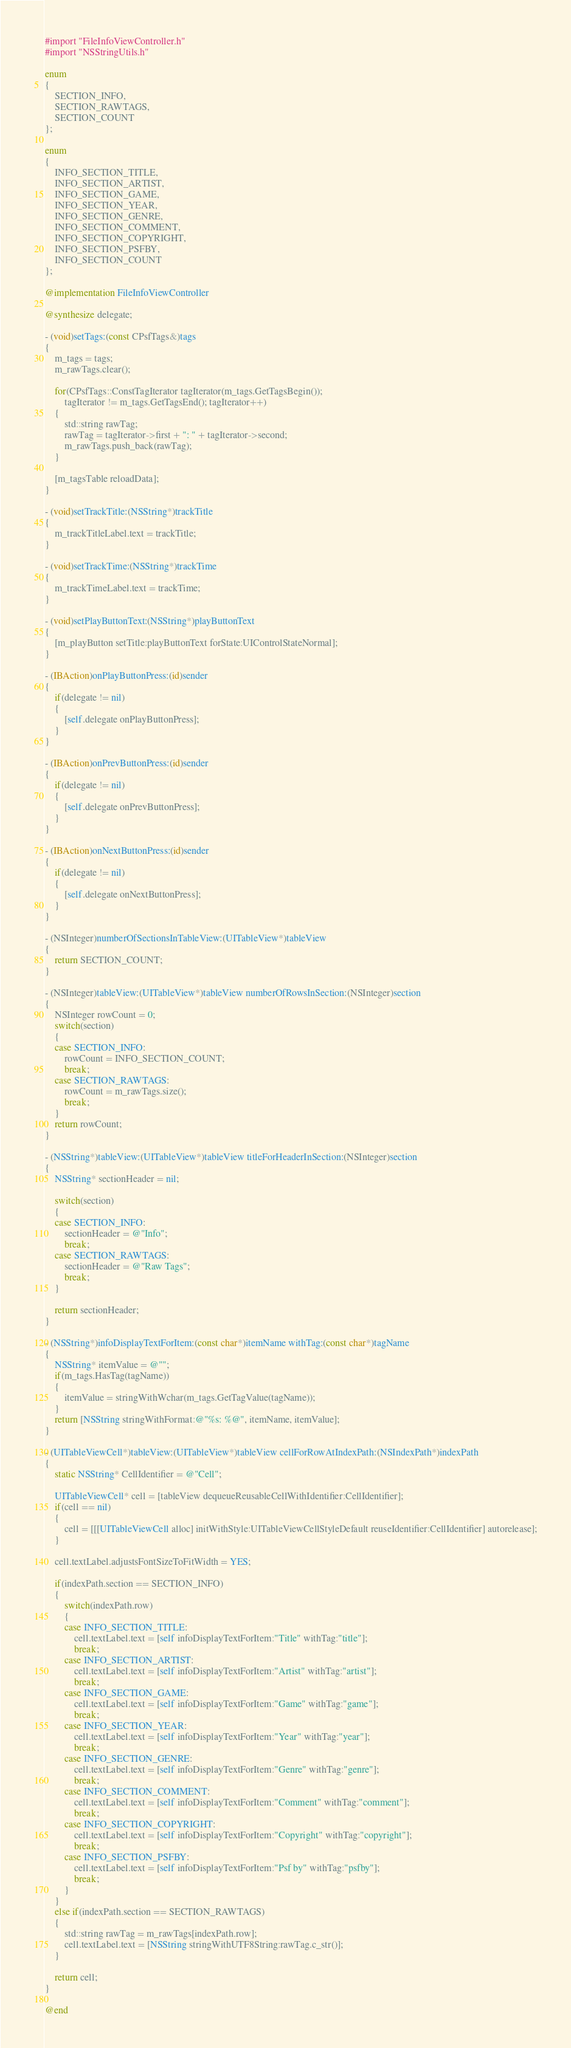<code> <loc_0><loc_0><loc_500><loc_500><_ObjectiveC_>#import "FileInfoViewController.h"
#import "NSStringUtils.h"

enum
{
	SECTION_INFO,
	SECTION_RAWTAGS,
	SECTION_COUNT
};

enum
{
	INFO_SECTION_TITLE,
	INFO_SECTION_ARTIST,
	INFO_SECTION_GAME,
	INFO_SECTION_YEAR,
	INFO_SECTION_GENRE,
	INFO_SECTION_COMMENT,
	INFO_SECTION_COPYRIGHT,
	INFO_SECTION_PSFBY,
	INFO_SECTION_COUNT
};

@implementation FileInfoViewController

@synthesize delegate;

- (void)setTags:(const CPsfTags&)tags
{
	m_tags = tags;
	m_rawTags.clear();

	for(CPsfTags::ConstTagIterator tagIterator(m_tags.GetTagsBegin());
	    tagIterator != m_tags.GetTagsEnd(); tagIterator++)
	{
		std::string rawTag;
		rawTag = tagIterator->first + ": " + tagIterator->second;
		m_rawTags.push_back(rawTag);
	}

	[m_tagsTable reloadData];
}

- (void)setTrackTitle:(NSString*)trackTitle
{
	m_trackTitleLabel.text = trackTitle;
}

- (void)setTrackTime:(NSString*)trackTime
{
	m_trackTimeLabel.text = trackTime;
}

- (void)setPlayButtonText:(NSString*)playButtonText
{
	[m_playButton setTitle:playButtonText forState:UIControlStateNormal];
}

- (IBAction)onPlayButtonPress:(id)sender
{
	if(delegate != nil)
	{
		[self.delegate onPlayButtonPress];
	}
}

- (IBAction)onPrevButtonPress:(id)sender
{
	if(delegate != nil)
	{
		[self.delegate onPrevButtonPress];
	}
}

- (IBAction)onNextButtonPress:(id)sender
{
	if(delegate != nil)
	{
		[self.delegate onNextButtonPress];
	}
}

- (NSInteger)numberOfSectionsInTableView:(UITableView*)tableView
{
	return SECTION_COUNT;
}

- (NSInteger)tableView:(UITableView*)tableView numberOfRowsInSection:(NSInteger)section
{
	NSInteger rowCount = 0;
	switch(section)
	{
	case SECTION_INFO:
		rowCount = INFO_SECTION_COUNT;
		break;
	case SECTION_RAWTAGS:
		rowCount = m_rawTags.size();
		break;
	}
	return rowCount;
}

- (NSString*)tableView:(UITableView*)tableView titleForHeaderInSection:(NSInteger)section
{
	NSString* sectionHeader = nil;

	switch(section)
	{
	case SECTION_INFO:
		sectionHeader = @"Info";
		break;
	case SECTION_RAWTAGS:
		sectionHeader = @"Raw Tags";
		break;
	}

	return sectionHeader;
}

- (NSString*)infoDisplayTextForItem:(const char*)itemName withTag:(const char*)tagName
{
	NSString* itemValue = @"";
	if(m_tags.HasTag(tagName))
	{
		itemValue = stringWithWchar(m_tags.GetTagValue(tagName));
	}
	return [NSString stringWithFormat:@"%s: %@", itemName, itemValue];
}

- (UITableViewCell*)tableView:(UITableView*)tableView cellForRowAtIndexPath:(NSIndexPath*)indexPath
{
	static NSString* CellIdentifier = @"Cell";

	UITableViewCell* cell = [tableView dequeueReusableCellWithIdentifier:CellIdentifier];
	if(cell == nil)
	{
		cell = [[[UITableViewCell alloc] initWithStyle:UITableViewCellStyleDefault reuseIdentifier:CellIdentifier] autorelease];
	}

	cell.textLabel.adjustsFontSizeToFitWidth = YES;

	if(indexPath.section == SECTION_INFO)
	{
		switch(indexPath.row)
		{
		case INFO_SECTION_TITLE:
			cell.textLabel.text = [self infoDisplayTextForItem:"Title" withTag:"title"];
			break;
		case INFO_SECTION_ARTIST:
			cell.textLabel.text = [self infoDisplayTextForItem:"Artist" withTag:"artist"];
			break;
		case INFO_SECTION_GAME:
			cell.textLabel.text = [self infoDisplayTextForItem:"Game" withTag:"game"];
			break;
		case INFO_SECTION_YEAR:
			cell.textLabel.text = [self infoDisplayTextForItem:"Year" withTag:"year"];
			break;
		case INFO_SECTION_GENRE:
			cell.textLabel.text = [self infoDisplayTextForItem:"Genre" withTag:"genre"];
			break;
		case INFO_SECTION_COMMENT:
			cell.textLabel.text = [self infoDisplayTextForItem:"Comment" withTag:"comment"];
			break;
		case INFO_SECTION_COPYRIGHT:
			cell.textLabel.text = [self infoDisplayTextForItem:"Copyright" withTag:"copyright"];
			break;
		case INFO_SECTION_PSFBY:
			cell.textLabel.text = [self infoDisplayTextForItem:"Psf by" withTag:"psfby"];
			break;
		}
	}
	else if(indexPath.section == SECTION_RAWTAGS)
	{
		std::string rawTag = m_rawTags[indexPath.row];
		cell.textLabel.text = [NSString stringWithUTF8String:rawTag.c_str()];
	}

	return cell;
}

@end
</code> 